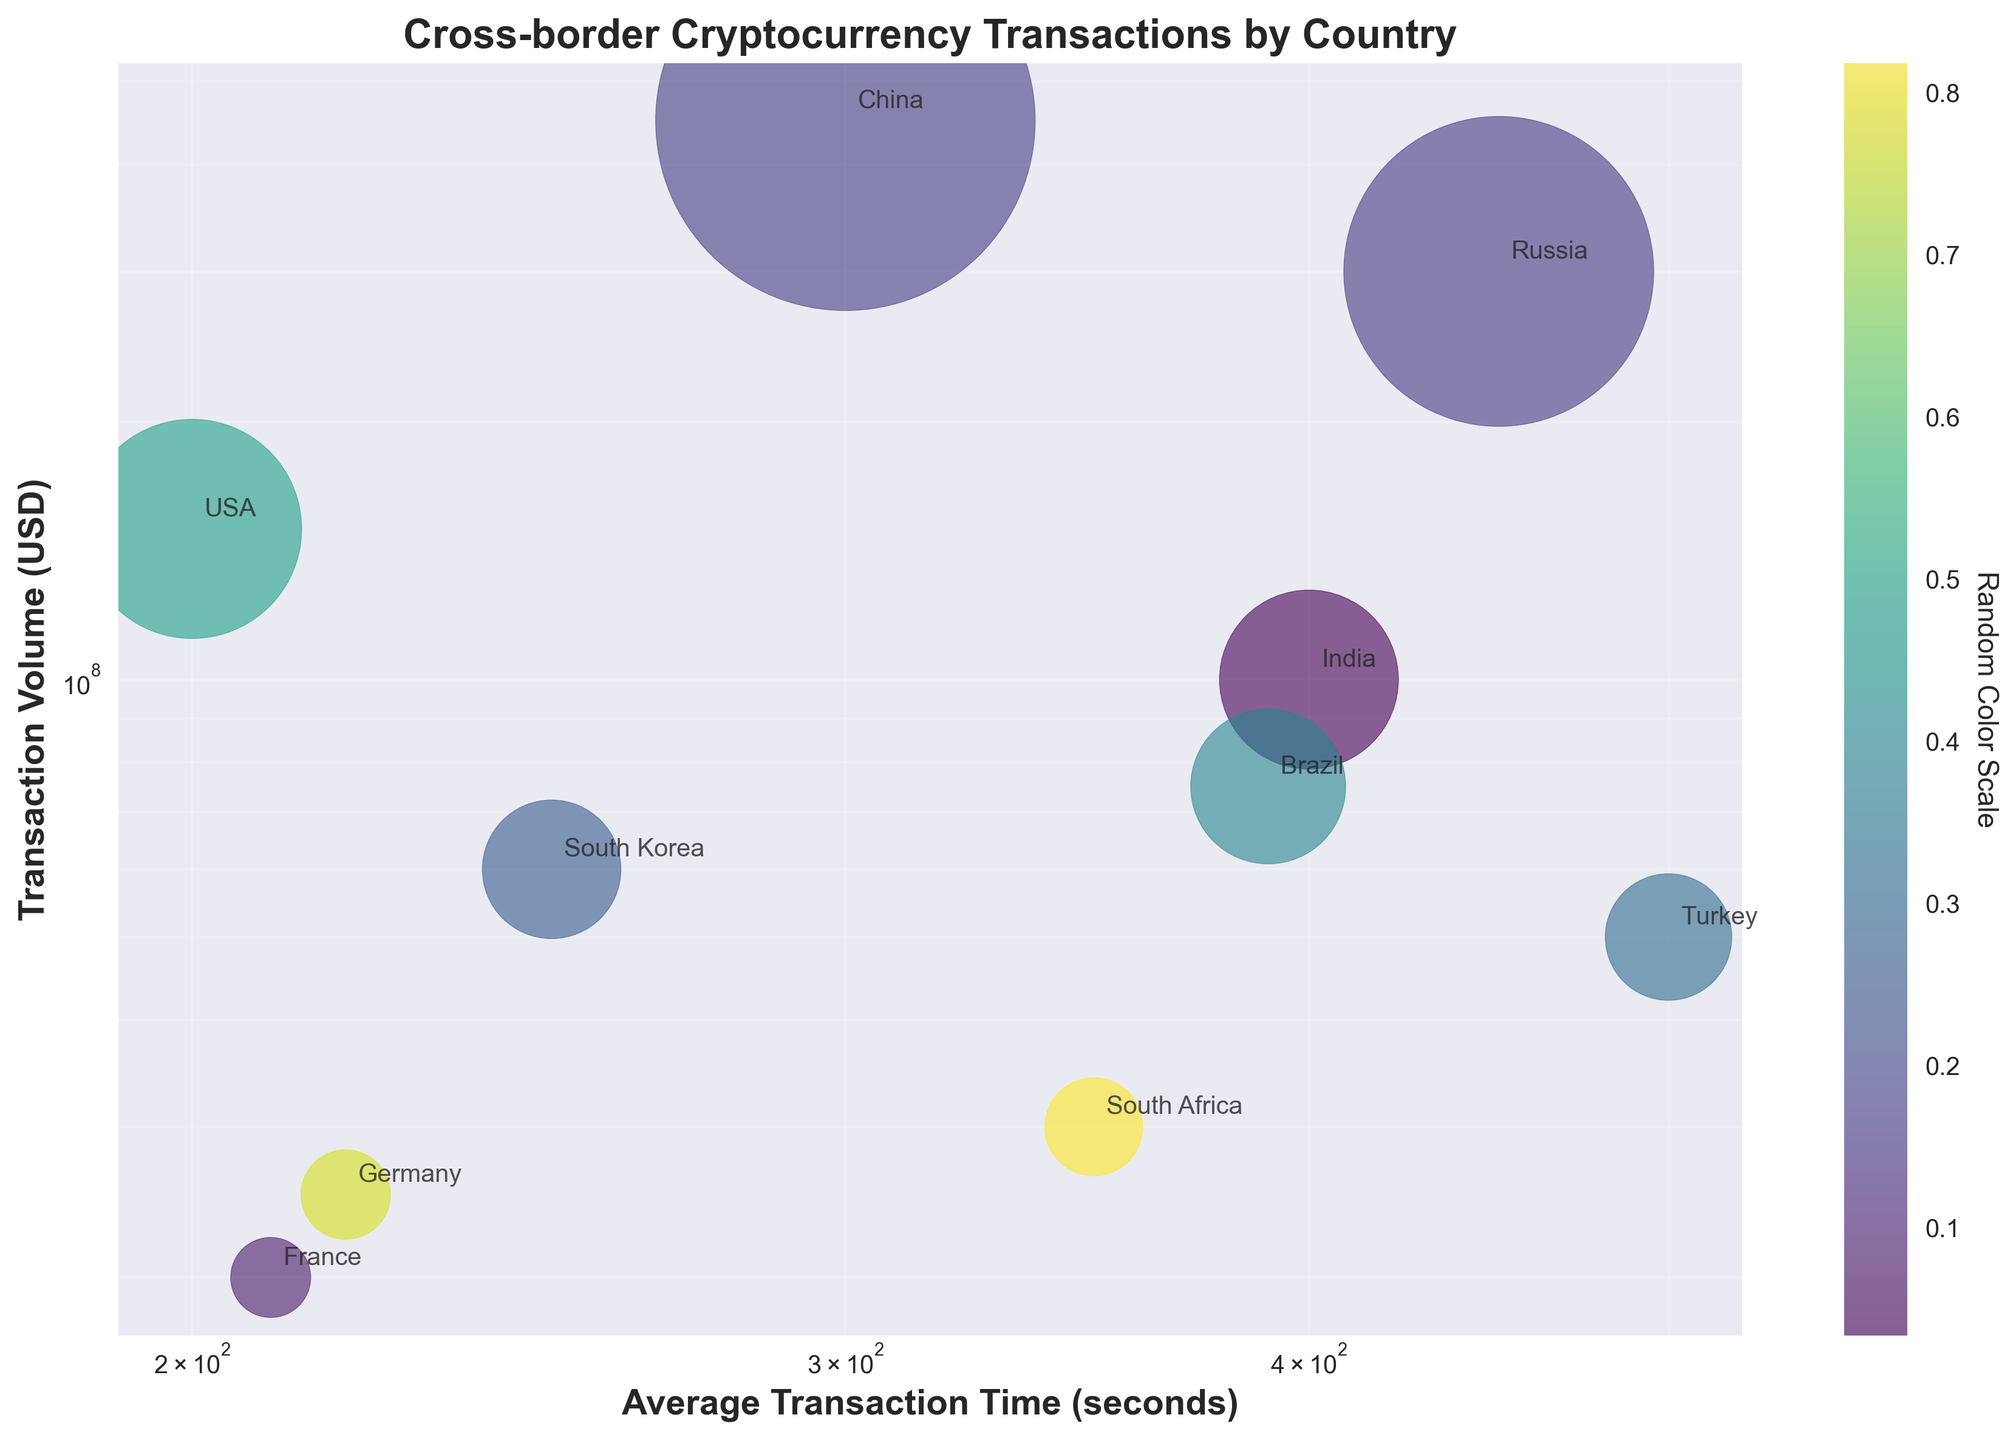What is the title of the figure? The title is usually located at the top of the figure and is meant to succinctly describe what the figure represents. Here it reads as "Cross-border Cryptocurrency Transactions by Country".
Answer: Cross-border Cryptocurrency Transactions by Country Which country has the highest transaction volume? Look for the data point with the highest value on the y-axis. China has the highest transaction volume in the figure.
Answer: China What is the color scale representing? The color bar is labeled 'Random Color Scale', indicating that the colors do not pertain to any specific measurement or category.
Answer: Random color scale What is the average transaction time for the USA? Identify the data point labeled "USA" and then read its x-coordinate on the log scale, which is around 200 seconds.
Answer: 200 seconds Which countries have transaction volumes below $50,000,000? Identify data points below the $50,000,000 mark on the log-scale y-axis. South Africa, Germany, and France are below this threshold.
Answer: South Africa, Germany, France What is the difference in average transaction time between Russia and South Korea? Locate the x-coordinates for Russia (450) and South Korea (250) and calculate the difference: 450 - 250 = 200 seconds.
Answer: 200 seconds Which country has the longest average transaction time, and what is it? Identify the data point furthest to the right on the x-axis. Turkey has the longest average transaction time of 500 seconds.
Answer: Turkey, 500 seconds Compare the transaction volumes of India and Brazil. Which country has a higher transaction volume? Locate and compare the y-coordinates of data points for India (100,000,000) and Brazil (75,000,000). India has a higher transaction volume.
Answer: India Is there a general trend between transaction volume and average transaction time? Observe the clustering of data points. There appears to be no clear trend as points are scattered. Some countries with higher volumes have lower times and vice versa.
Answer: No clear trend What is the range of transaction volumes observed in the figure? Identify the highest and lowest values on the y-axis. The highest is for China ($450,000,000) and the lowest is for France ($20,000,000). The range is $450,000,000 - $20,000,000 = $430,000,000.
Answer: $430,000,000 